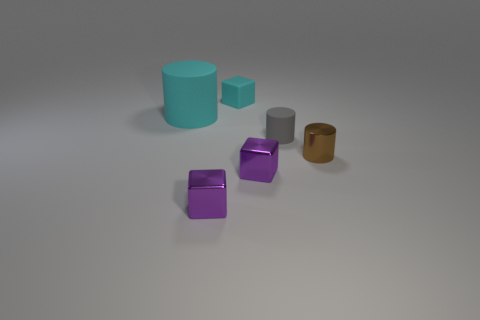Is the brown thing made of the same material as the cyan thing behind the cyan cylinder?
Provide a short and direct response. No. Is the number of rubber cubes that are on the left side of the big object less than the number of cyan rubber blocks to the left of the small matte block?
Your answer should be very brief. No. What material is the cyan thing on the right side of the big thing?
Your answer should be very brief. Rubber. What is the color of the cylinder that is in front of the big matte cylinder and on the left side of the brown metal object?
Your answer should be compact. Gray. What number of other objects are the same color as the small rubber cube?
Ensure brevity in your answer.  1. There is a small cylinder that is behind the small brown shiny object; what color is it?
Keep it short and to the point. Gray. Are there any purple metal objects that have the same size as the matte cube?
Your answer should be very brief. Yes. There is a gray cylinder that is the same size as the cyan block; what material is it?
Keep it short and to the point. Rubber. What number of objects are small things that are behind the big cyan rubber cylinder or tiny cylinders behind the tiny brown metallic cylinder?
Provide a short and direct response. 2. Are there any tiny purple shiny objects that have the same shape as the tiny cyan thing?
Your answer should be compact. Yes. 